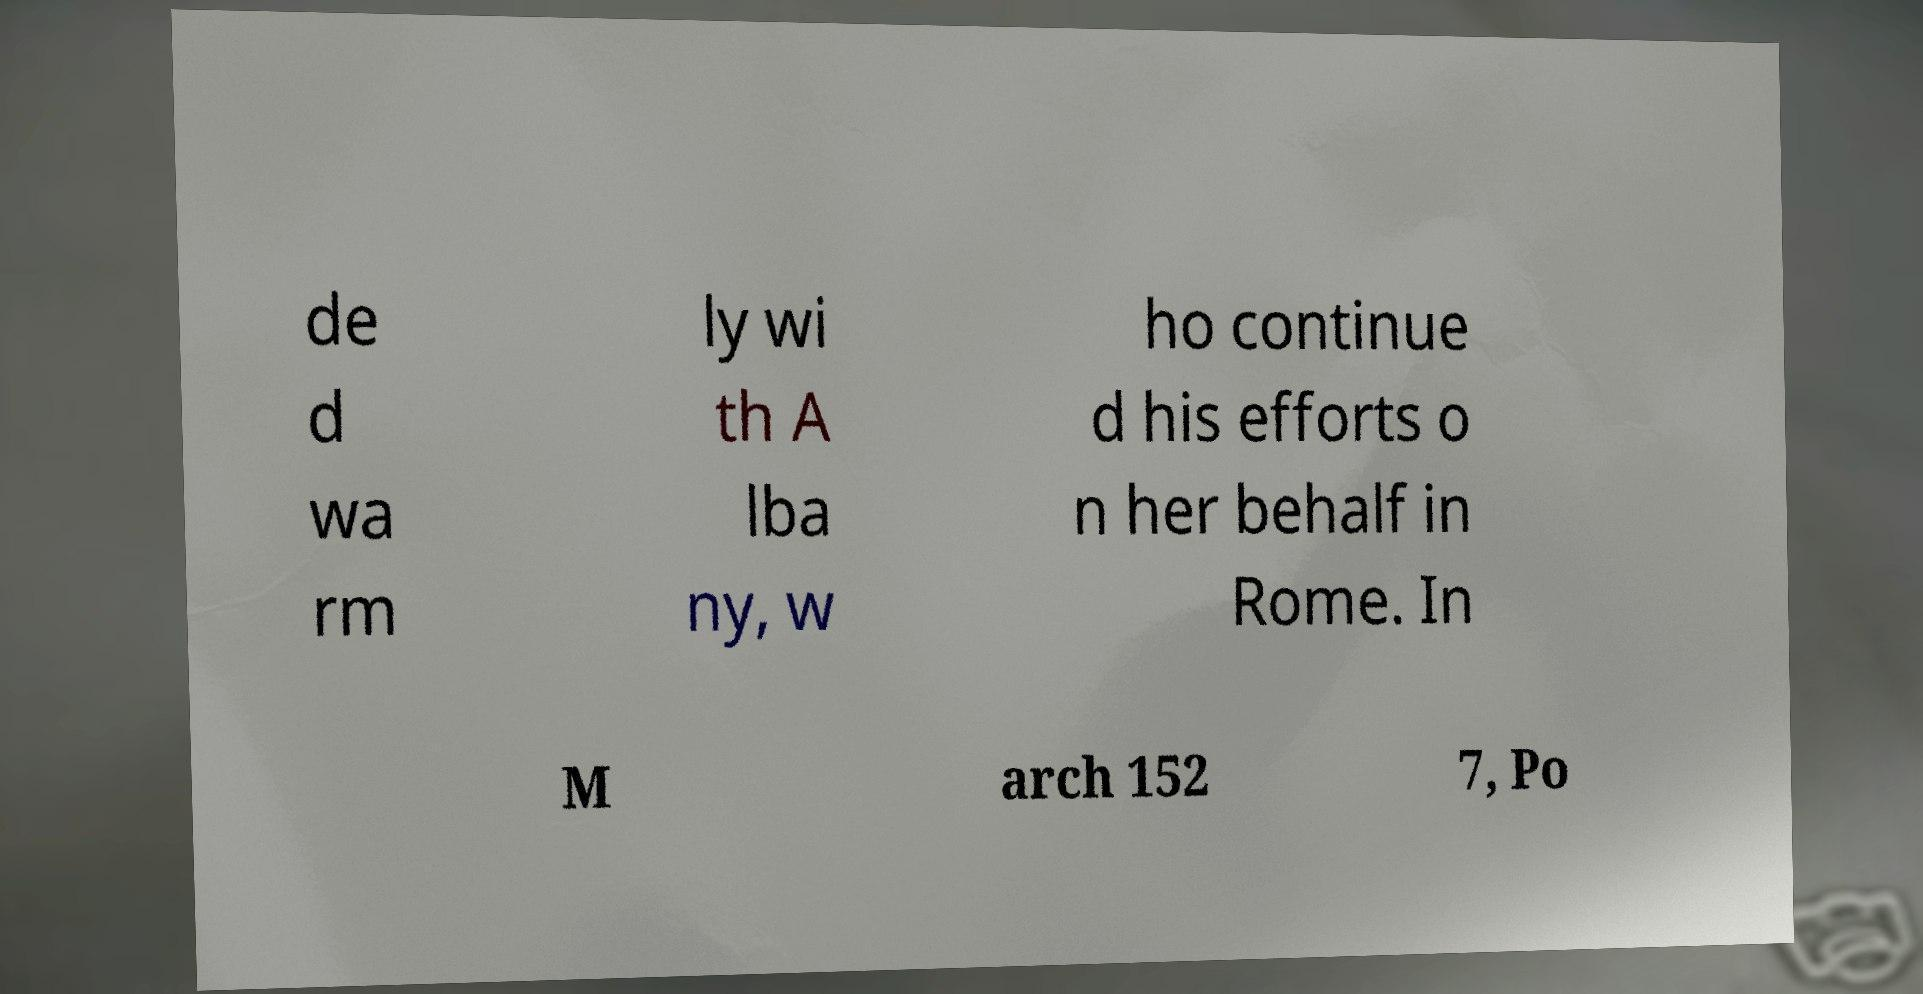Could you extract and type out the text from this image? de d wa rm ly wi th A lba ny, w ho continue d his efforts o n her behalf in Rome. In M arch 152 7, Po 